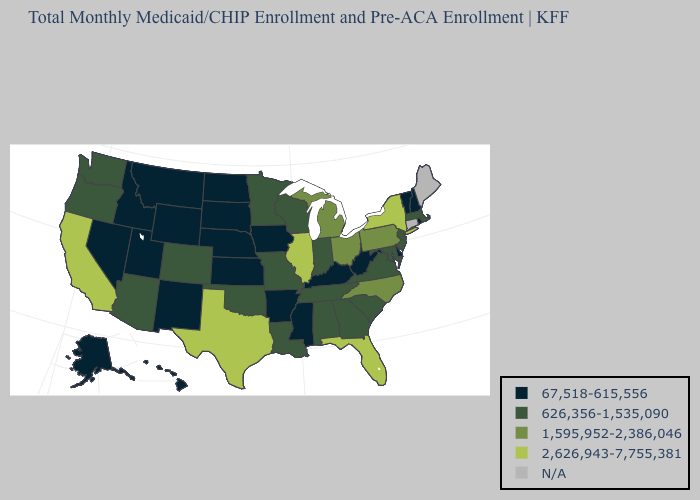What is the highest value in the USA?
Give a very brief answer. 2,626,943-7,755,381. What is the value of Pennsylvania?
Answer briefly. 1,595,952-2,386,046. Name the states that have a value in the range 1,595,952-2,386,046?
Answer briefly. Michigan, North Carolina, Ohio, Pennsylvania. Name the states that have a value in the range 1,595,952-2,386,046?
Keep it brief. Michigan, North Carolina, Ohio, Pennsylvania. What is the highest value in the USA?
Answer briefly. 2,626,943-7,755,381. What is the value of Oregon?
Write a very short answer. 626,356-1,535,090. What is the value of Connecticut?
Answer briefly. N/A. Does Illinois have the highest value in the MidWest?
Be succinct. Yes. Which states have the lowest value in the MidWest?
Be succinct. Iowa, Kansas, Nebraska, North Dakota, South Dakota. Name the states that have a value in the range 67,518-615,556?
Be succinct. Alaska, Arkansas, Delaware, Hawaii, Idaho, Iowa, Kansas, Kentucky, Mississippi, Montana, Nebraska, Nevada, New Hampshire, New Mexico, North Dakota, Rhode Island, South Dakota, Utah, Vermont, West Virginia, Wyoming. Name the states that have a value in the range N/A?
Short answer required. Connecticut, Maine. Does Michigan have the lowest value in the USA?
Short answer required. No. 